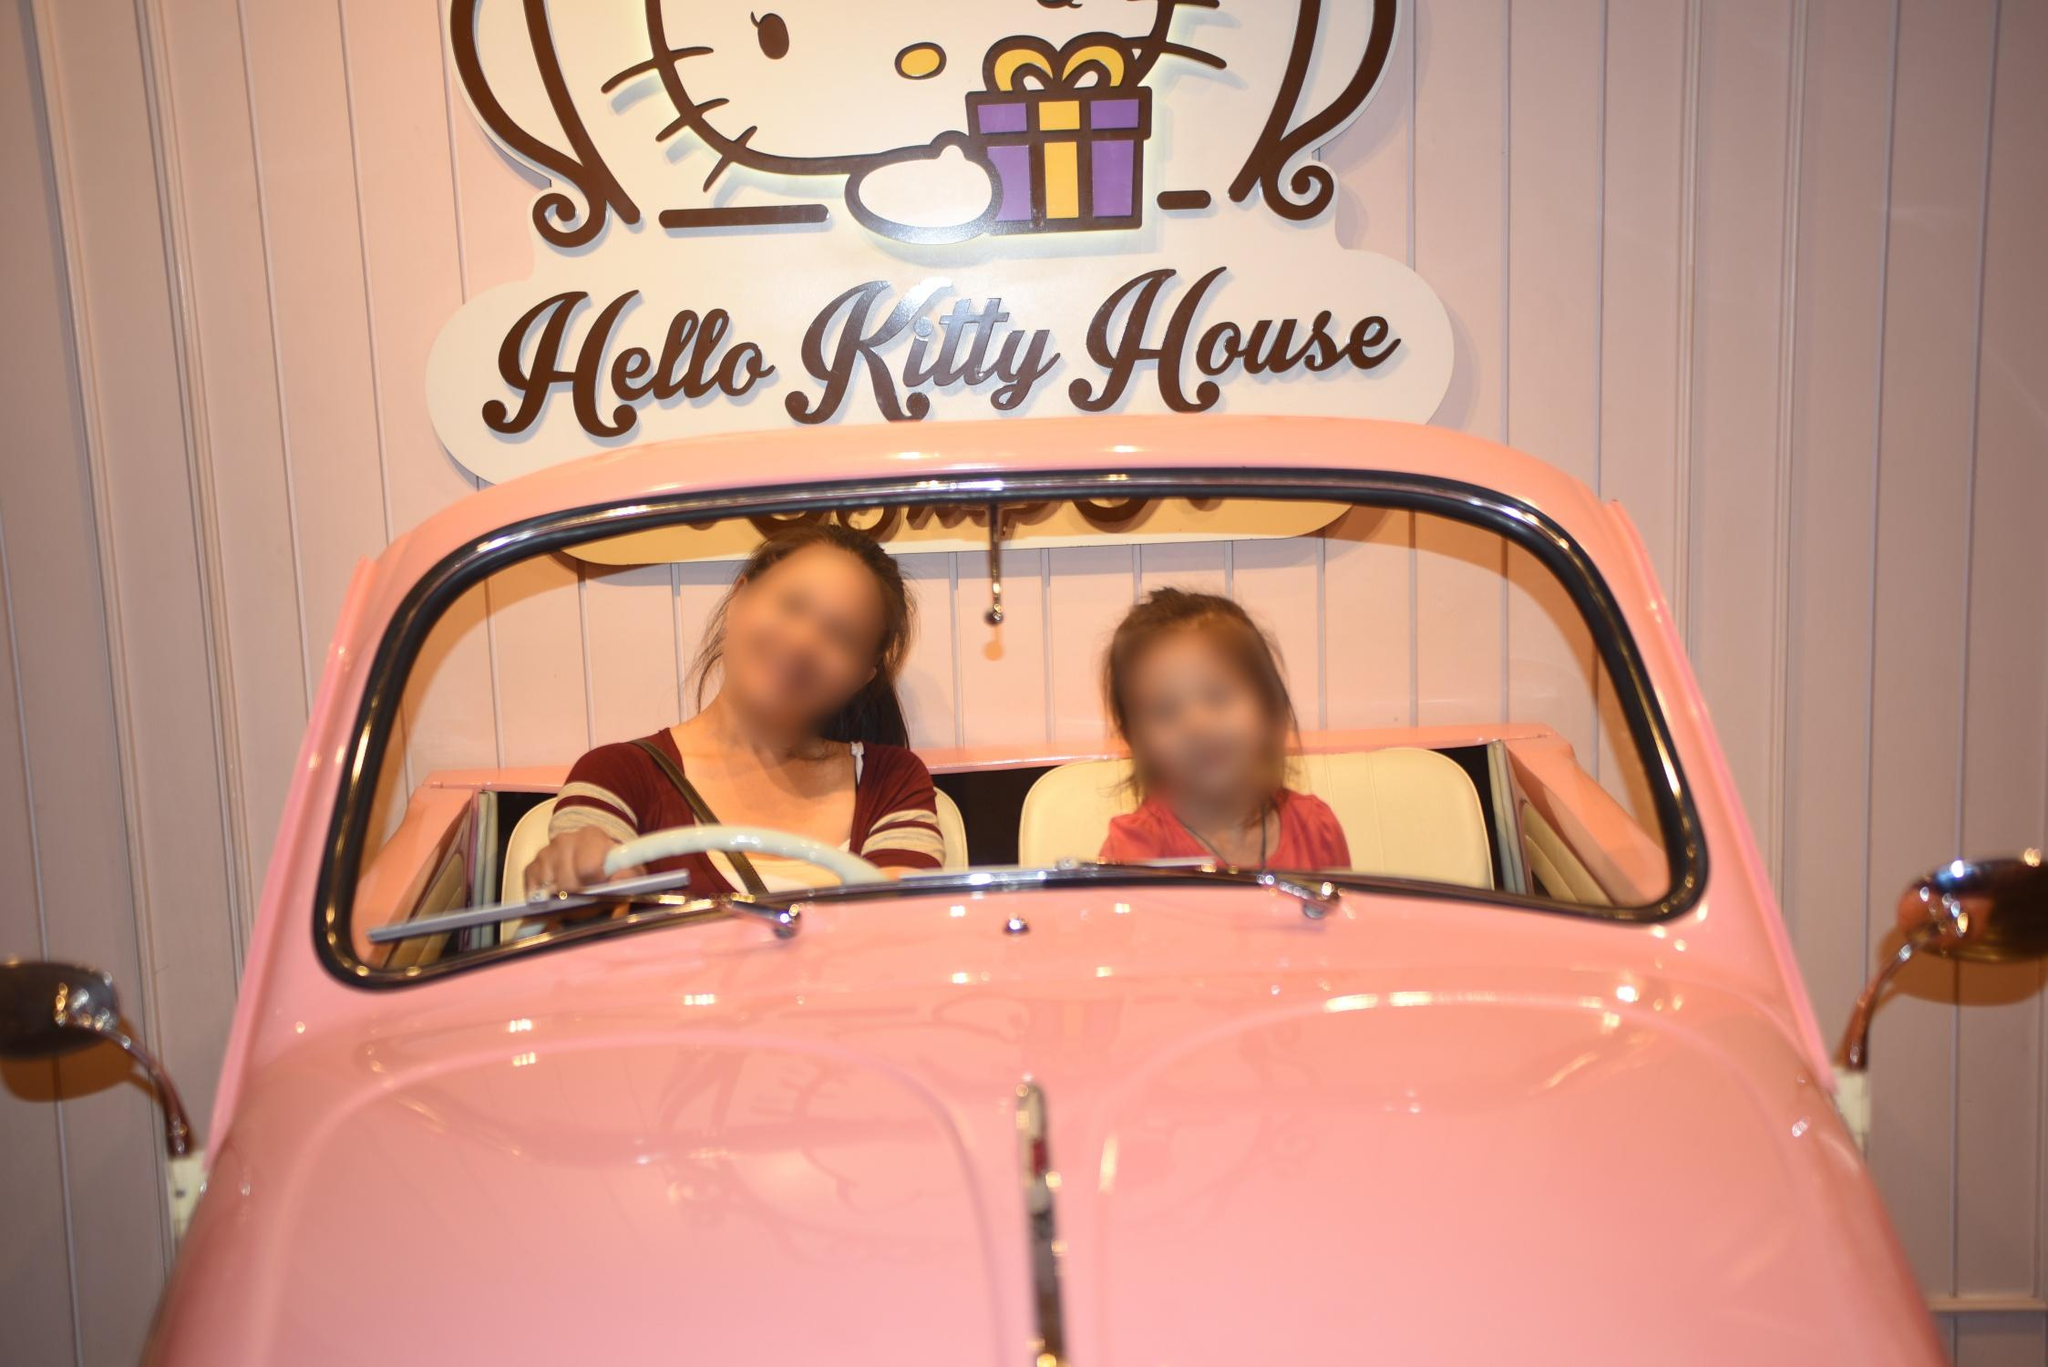What's happening in the scene? The image showcases two individuals posing inside a pink car that matches the charming aesthetics of the 'Hello Kitty House'. The pink and white color scheme suggests the car is a part of the themed experience, and it is parked against a striped wall that complements the overall Hello Kitty theme. While the car's occupants appear blurred, likely due to the camera's focus rather than their motion, they seem to be enjoying the moment. The sign above indicates that this is a themed setting intended for visitors to immerse themselves in the delightful world of Hello Kitty. 